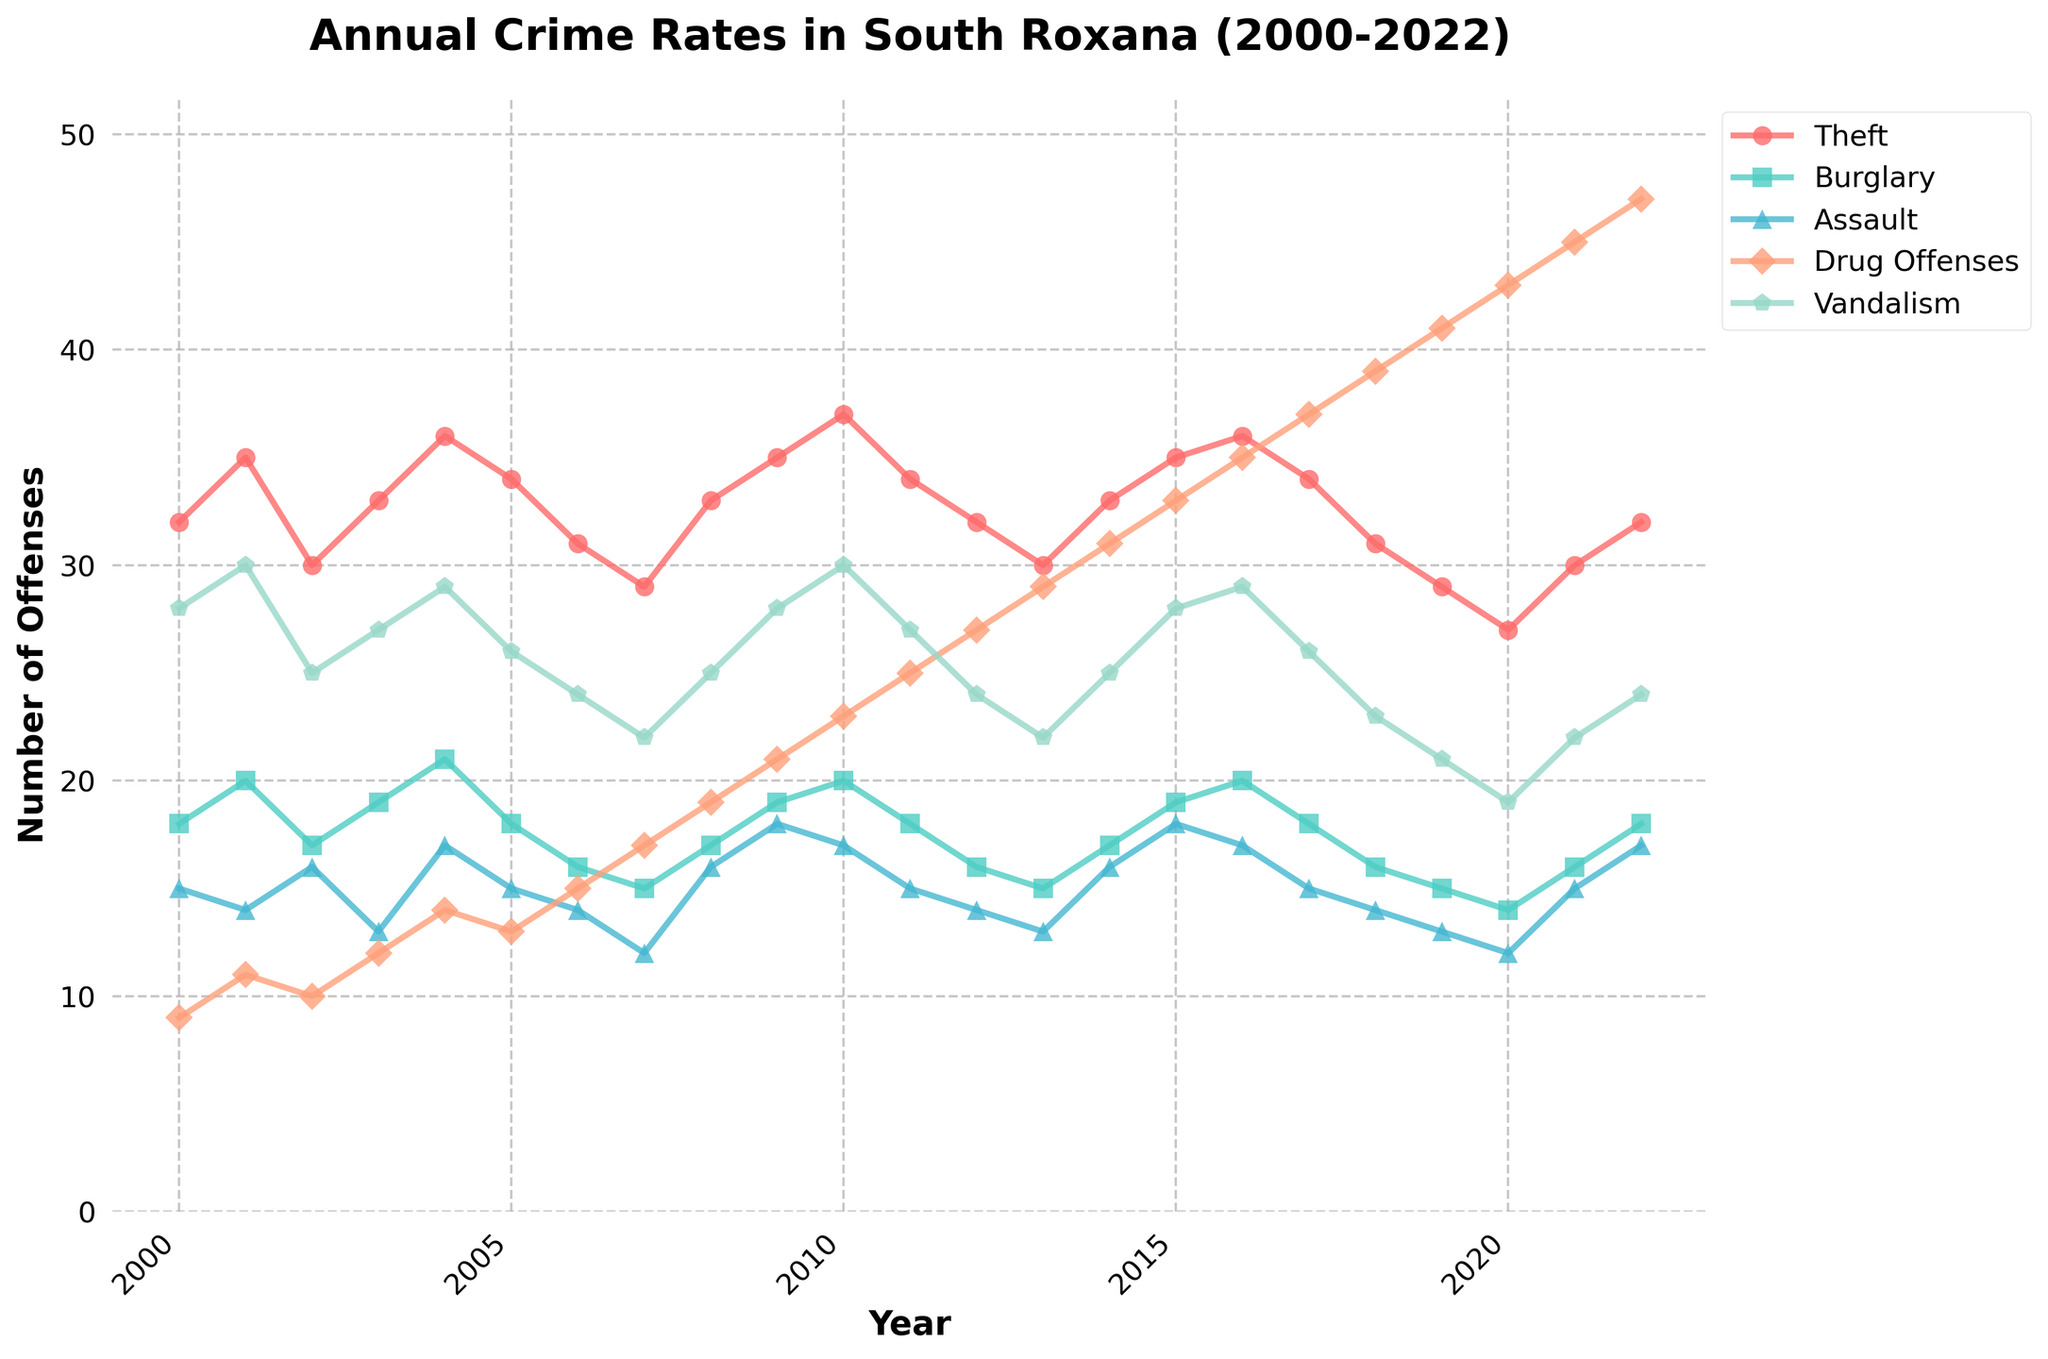What is the trend in the number of drug offenses from 2000 to 2022? The line for drug offenses shows a marked increasing trend from 2000 to 2022. Starting at a low point of 9 offenses in 2000, the numbers rise consistently every year, reaching the highest point of 47 offenses in 2022.
Answer: Increasing Which year saw the highest number of thefts? In the chart, the peak of the line for theft is observed in the year 2010, where the number of thefts reaches 37.
Answer: 2010 Comparing 2000 and 2022, which type of crime saw the largest increase in the number of offenses? By analyzing the differences between 2000 and 2022 for each crime type, the increase for each offense is: Theft: 0, Burglary: 0, Assault: 2, Drug Offenses: 38, Vandalism: -4. Drug offenses showed the largest increase with a rise of 38 offenses.
Answer: Drug Offenses Which category had the most offenses in 2022? By looking at the endpoints of the lines for each category in 2022, drug offenses have the highest value, with 47 offenses reported.
Answer: Drug Offenses During which period did the number of burglaries remain relatively stable? The line for burglaries remains relatively stable between 2000 and around 2019, with only minor fluctuations between 14 and 21.
Answer: 2000-2019 What is the average number of vandalism incidents from 2000 to 2022? To find the average, sum the number of vandalism incidents for each year from 2000 to 2022 and divide by 23. Calculation: (28+30+25+27+29+26+24+22+25+28+30+27+24+22+25+28+29+26+23+21+19+22+24) / 23 = 26.04 (approx).
Answer: 26 Which year shows the highest increase in drug offenses compared to the previous year? Observing the steepest upward slope in the drug offenses line, the most significant year-on-year increase occurs between 2012 (27 offenses) and 2013 (29 offenses), which is the largest single increase of 2 offenses.
Answer: 2012-2013 Is there any year where the number of burglaries and assaults is equal? By comparing the data points for both lines, there is no year where burglaries and assaults have the exact same number of offenses.
Answer: No Which crime type experienced a decline from 2000 to 2020? By observing the trends, vandalism declined from 28 offenses in 2000 to 19 in 2020.
Answer: Vandalism 